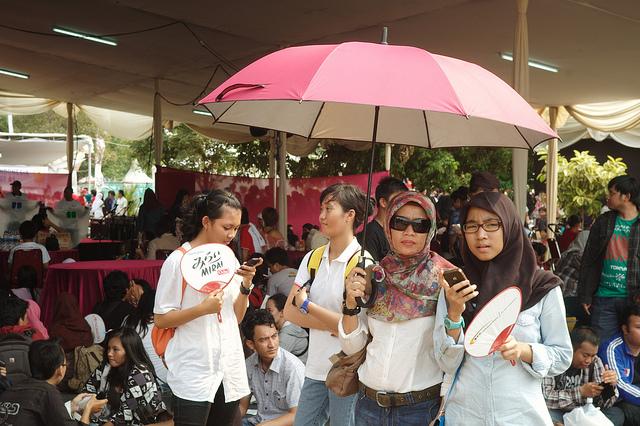Who many people are shown?
Give a very brief answer. 20. Is one of the girls wearing a headscarf?
Concise answer only. Yes. What color is the umbrella?
Give a very brief answer. Pink. 